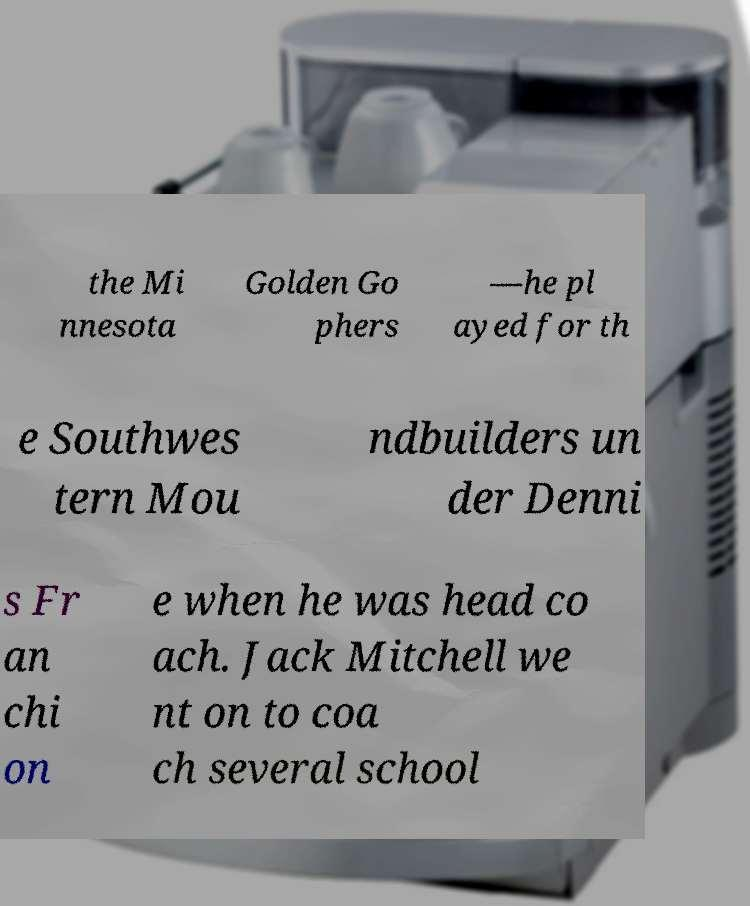Please read and relay the text visible in this image. What does it say? the Mi nnesota Golden Go phers —he pl ayed for th e Southwes tern Mou ndbuilders un der Denni s Fr an chi on e when he was head co ach. Jack Mitchell we nt on to coa ch several school 